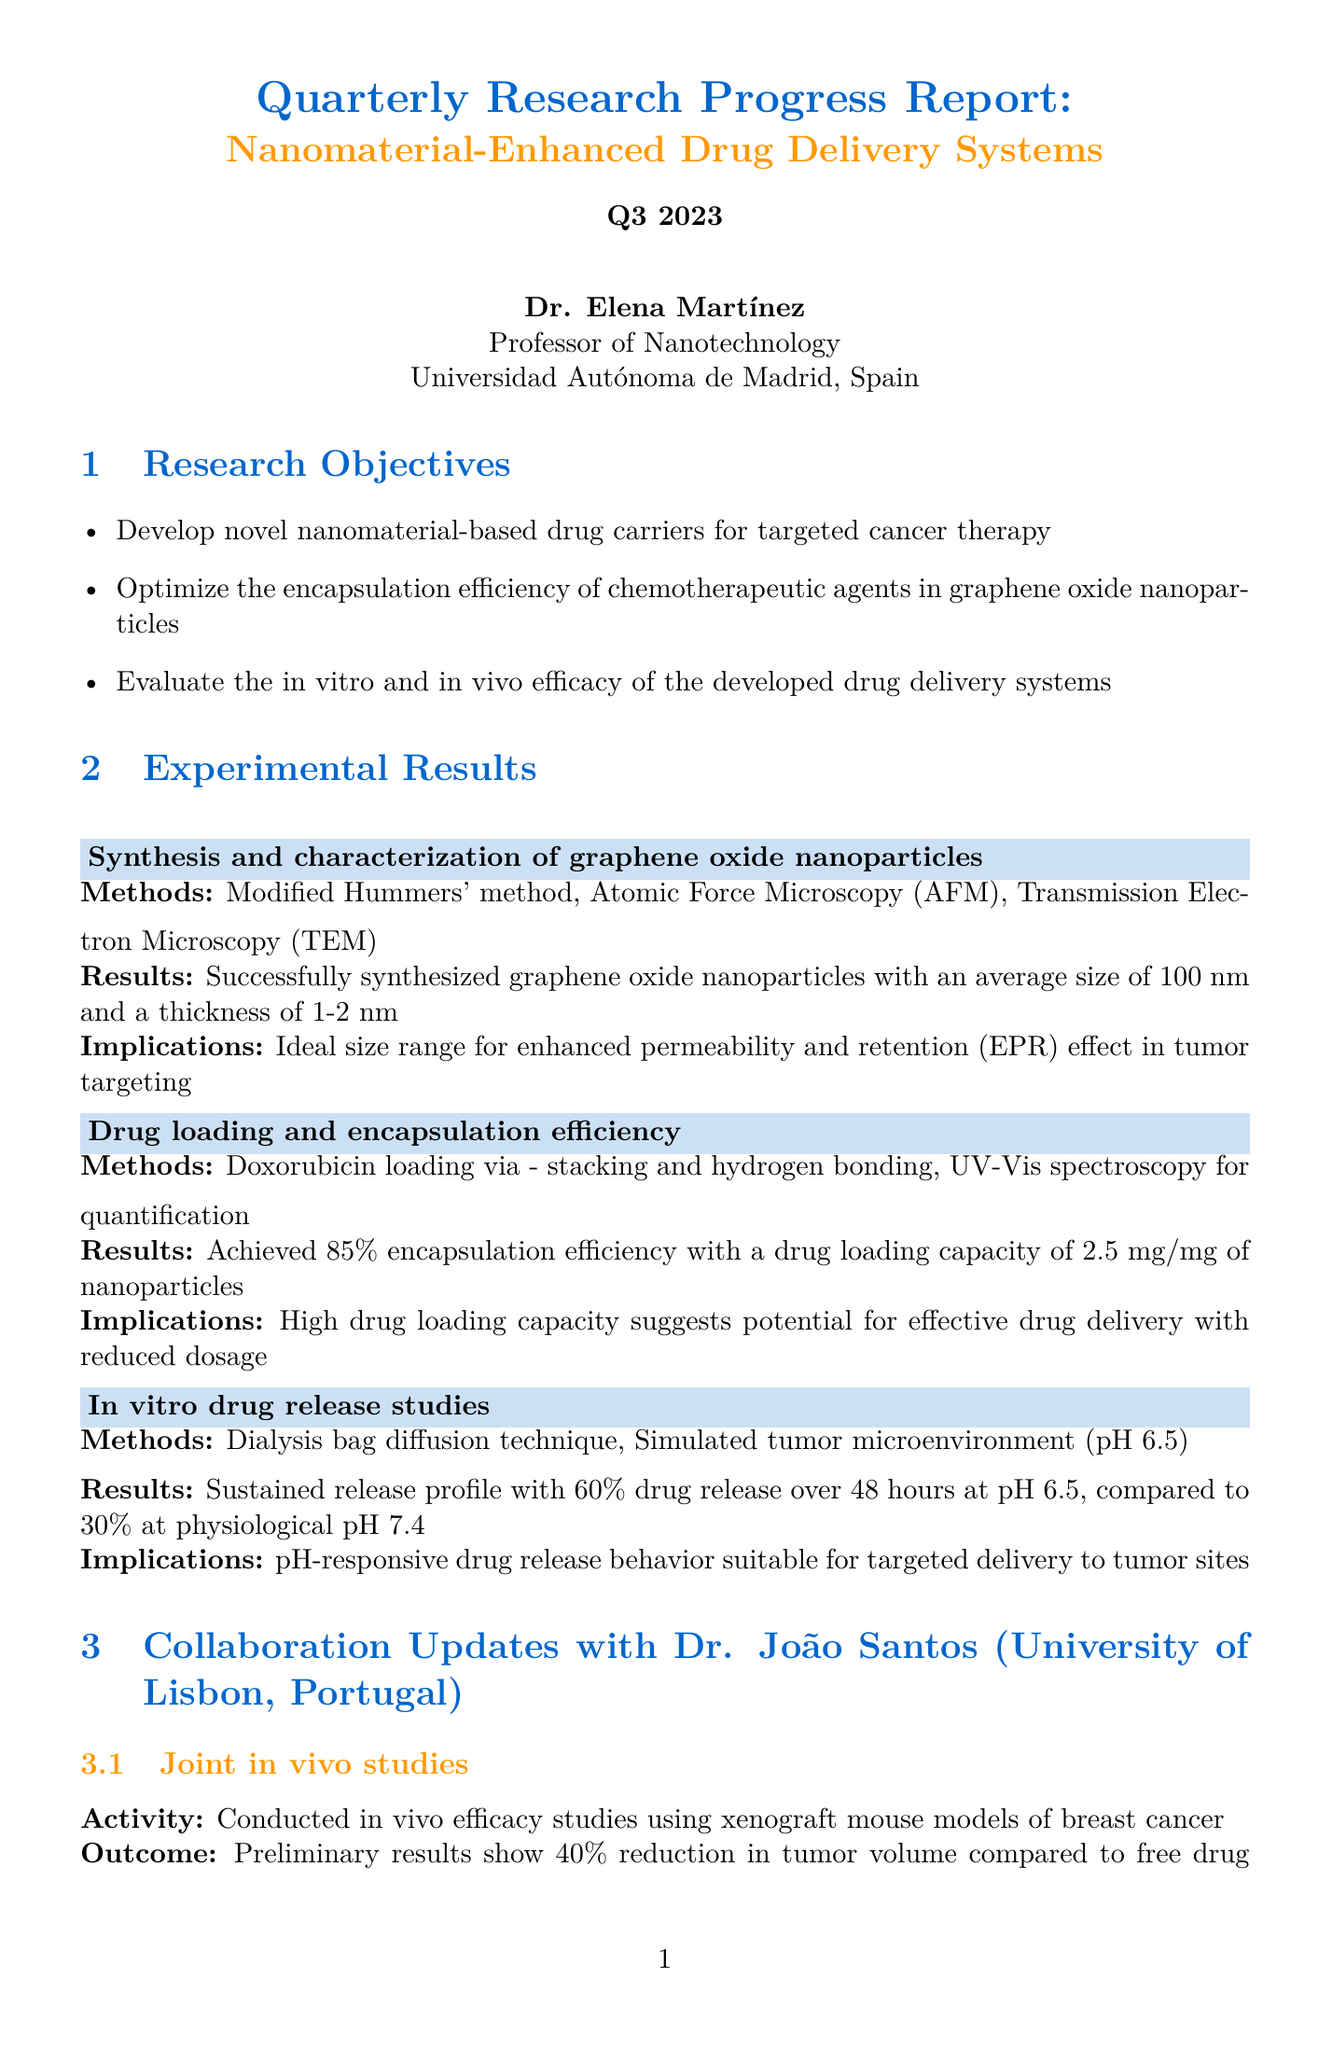What are the research objectives listed in the report? The research objectives are detailed in the section titled "Research Objectives," which identifies the main goals of the study.
Answer: Develop novel nanomaterial-based drug carriers for targeted cancer therapy, optimize the encapsulation efficiency of chemotherapeutic agents in graphene oxide nanoparticles, evaluate the in vitro and in vivo efficacy of the developed drug delivery systems What is the average size of the graphene oxide nanoparticles synthesized? The section "Synthesis and characterization of graphene oxide nanoparticles" contains the results regarding the size of the nanoparticles.
Answer: 100 nm What was the encapsulation efficiency achieved in the drug loading experiment? The "Drug loading and encapsulation efficiency" section provides specific performance metrics of the drug loading process.
Answer: 85 percent What was the preliminary outcome of the joint in vivo studies conducted with Dr. Santos' team? The update on "Joint in vivo studies" outlines the effectiveness of the experiments done in collaboration with Dr. Santos.
Answer: 40 percent reduction in tumor volume compared to free drug administration What pH level showed a sustained release profile during the in vitro drug release studies? The results of the "In vitro drug release studies" section mention the different pH levels tested and their effects.
Answer: pH 6.5 What funding source supports the research? The section titled "Funding Status" specifies the current grant that is funding the research activities described in the report.
Answer: European Research Council (ERC) Consolidator Grant What is the status of the journal article titled "Graphene Oxide Nanocarriers for pH-Responsive Delivery of Doxorubicin in Breast Cancer Therapy"? The "Publications and Presentations" section indicates the review phase of the journal article.
Answer: Under review Which method is being investigated to improve nanoparticle stability during long-term storage? The "Challenges and Solutions" section addresses challenges faced during research and their respective solutions.
Answer: Investigating the use of trehalose as a cryoprotectant 